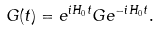<formula> <loc_0><loc_0><loc_500><loc_500>G ( t ) = e ^ { i H _ { 0 } t } G e ^ { - i H _ { 0 } t } .</formula> 